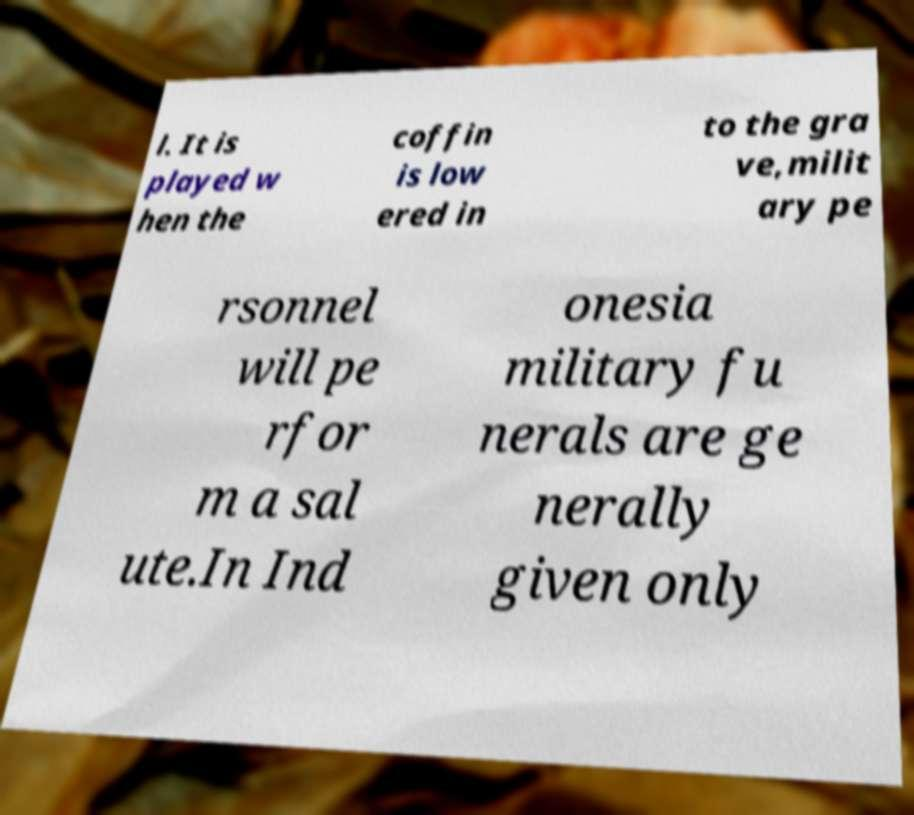Please identify and transcribe the text found in this image. l. It is played w hen the coffin is low ered in to the gra ve,milit ary pe rsonnel will pe rfor m a sal ute.In Ind onesia military fu nerals are ge nerally given only 